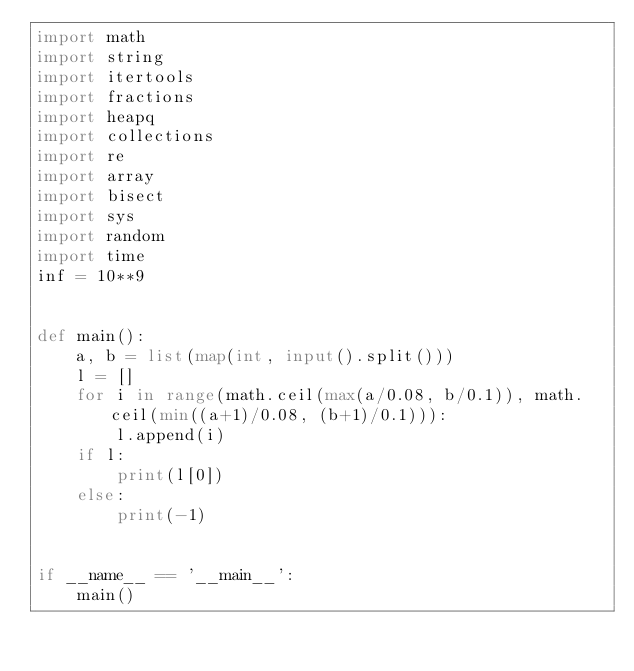<code> <loc_0><loc_0><loc_500><loc_500><_Python_>import math
import string
import itertools
import fractions
import heapq
import collections
import re
import array
import bisect
import sys
import random
import time
inf = 10**9


def main():
    a, b = list(map(int, input().split()))
    l = []
    for i in range(math.ceil(max(a/0.08, b/0.1)), math.ceil(min((a+1)/0.08, (b+1)/0.1))):
        l.append(i)
    if l:
        print(l[0])
    else:
        print(-1)


if __name__ == '__main__':
    main()
</code> 